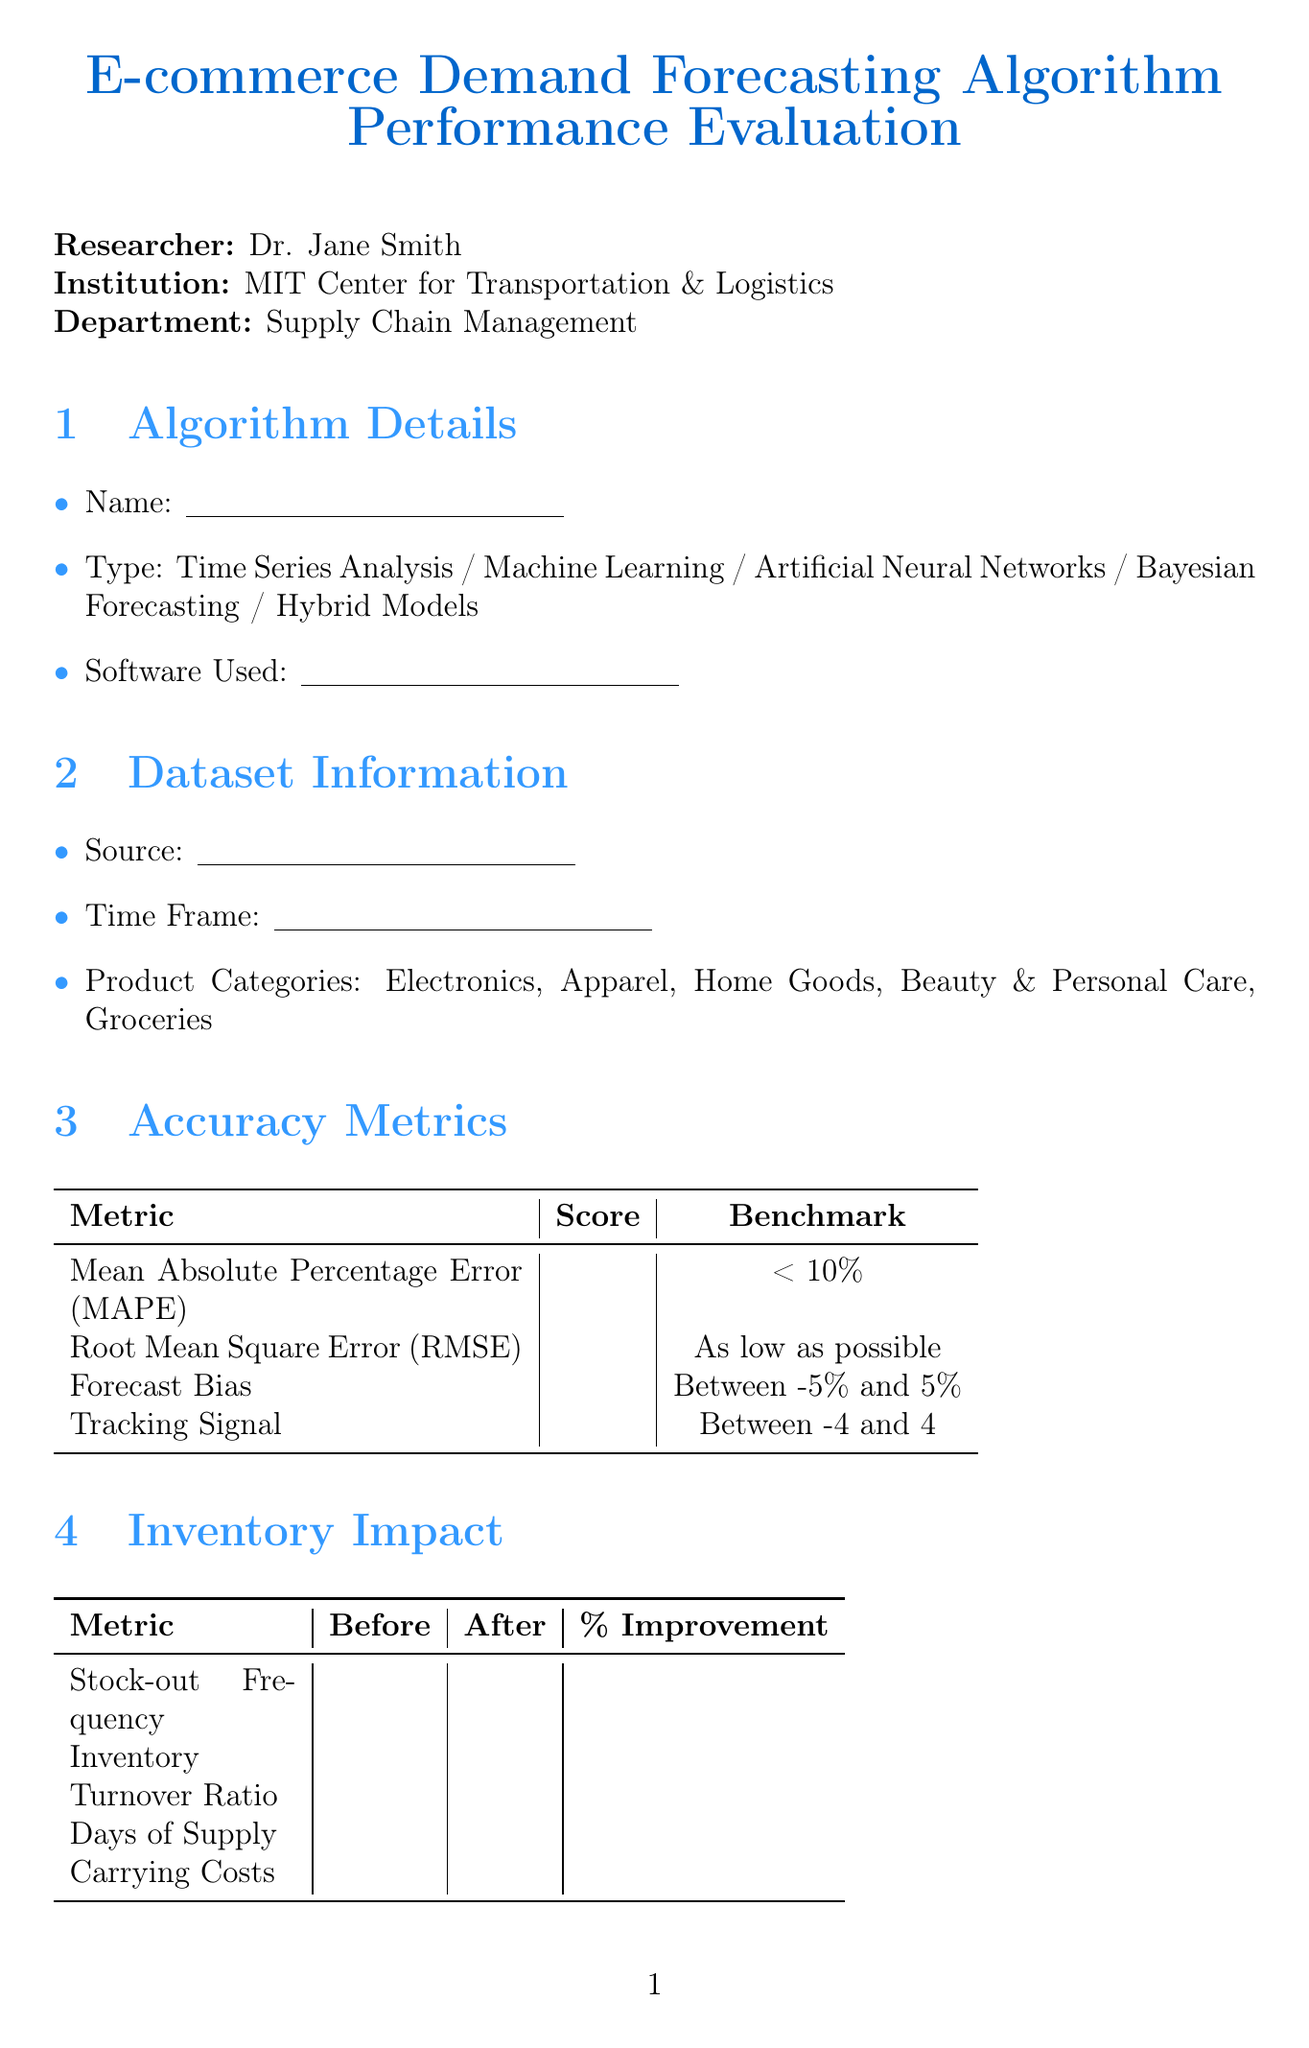what is the name of the researcher? The researcher's name is stated in the document under researcher information.
Answer: Dr. Jane Smith what is the type of algorithms listed? The document lists various types of algorithms in the algorithm details section.
Answer: Time Series Analysis, Machine Learning, Artificial Neural Networks, Bayesian Forecasting, Hybrid Models what is the benchmark for Mean Absolute Percentage Error (MAPE)? The benchmark for MAPE is specified in the accuracy metrics table.
Answer: Less than 10% what metric shows the improvement in stock-out frequency? This metric is found in the inventory impact section where various metrics are listed before and after implementation.
Answer: Stock-out Frequency what challenges are listed for demand forecasting? The document provides a list of challenges and limitations in a dedicated section.
Answer: Data Quality Issues, Computational Resources, Integration with Existing Systems, Handling Promotional Events, Adapting to Market Disruptions what is indicated as the overall weakness in the assessment? The overall weaknesses are to be filled out in the overall assessment section.
Answer: (To be filled out) what future development involves IoT? This information is found in the future developments section.
Answer: Integration with IoT devices for real-time data what is the role of the evaluator signature? The evaluator signature indicates approval or verification of the evaluation form.
Answer: Signature how is the order fulfillment rate categorized in operational efficiency? The order fulfillment rate is one of the metrics under operational efficiency listed in a table format.
Answer: Order Fulfillment Rate 